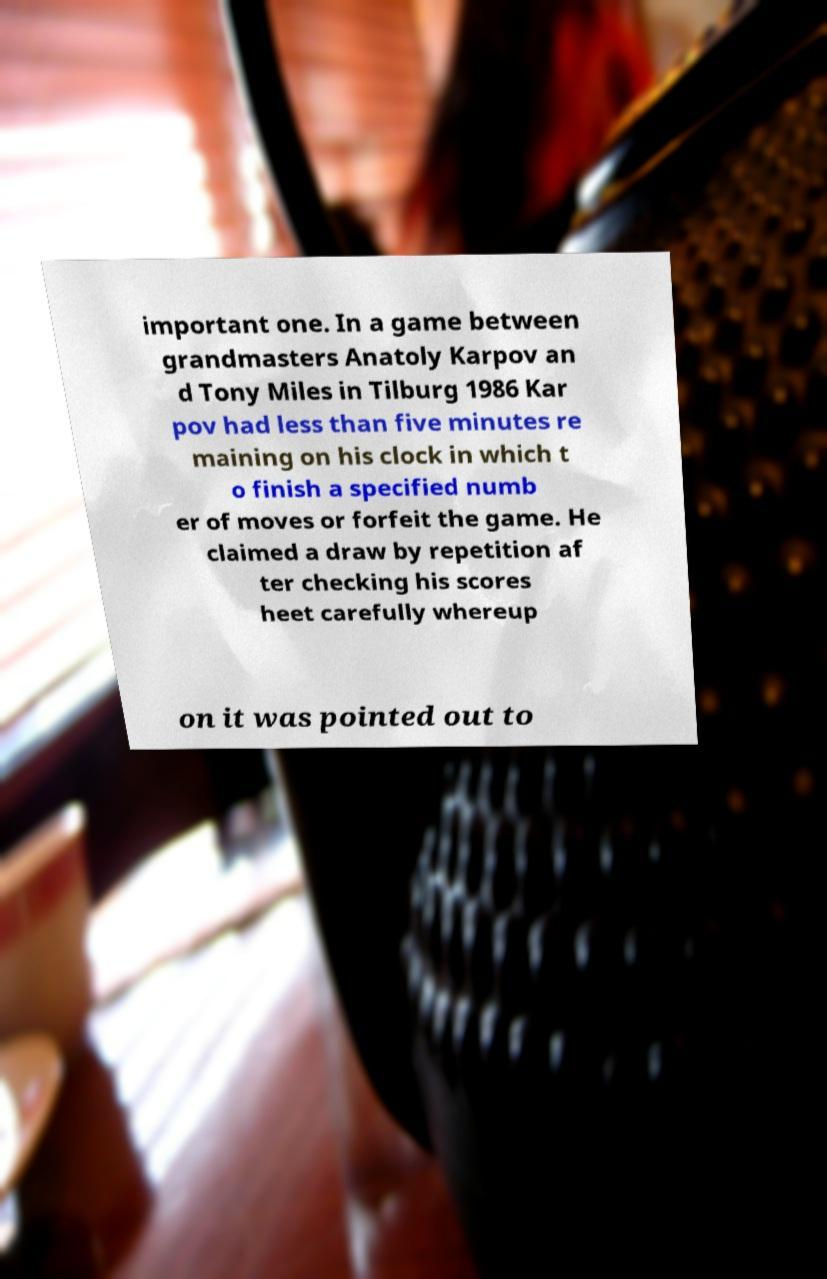There's text embedded in this image that I need extracted. Can you transcribe it verbatim? important one. In a game between grandmasters Anatoly Karpov an d Tony Miles in Tilburg 1986 Kar pov had less than five minutes re maining on his clock in which t o finish a specified numb er of moves or forfeit the game. He claimed a draw by repetition af ter checking his scores heet carefully whereup on it was pointed out to 